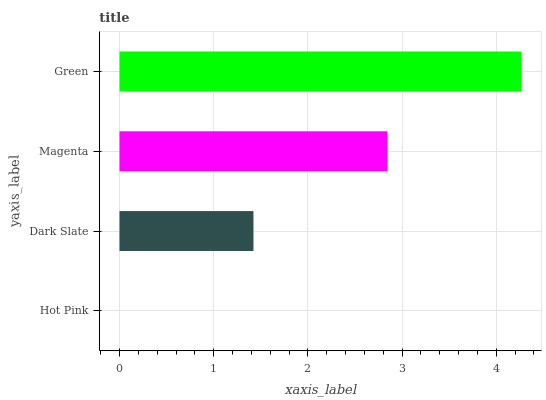Is Hot Pink the minimum?
Answer yes or no. Yes. Is Green the maximum?
Answer yes or no. Yes. Is Dark Slate the minimum?
Answer yes or no. No. Is Dark Slate the maximum?
Answer yes or no. No. Is Dark Slate greater than Hot Pink?
Answer yes or no. Yes. Is Hot Pink less than Dark Slate?
Answer yes or no. Yes. Is Hot Pink greater than Dark Slate?
Answer yes or no. No. Is Dark Slate less than Hot Pink?
Answer yes or no. No. Is Magenta the high median?
Answer yes or no. Yes. Is Dark Slate the low median?
Answer yes or no. Yes. Is Dark Slate the high median?
Answer yes or no. No. Is Hot Pink the low median?
Answer yes or no. No. 